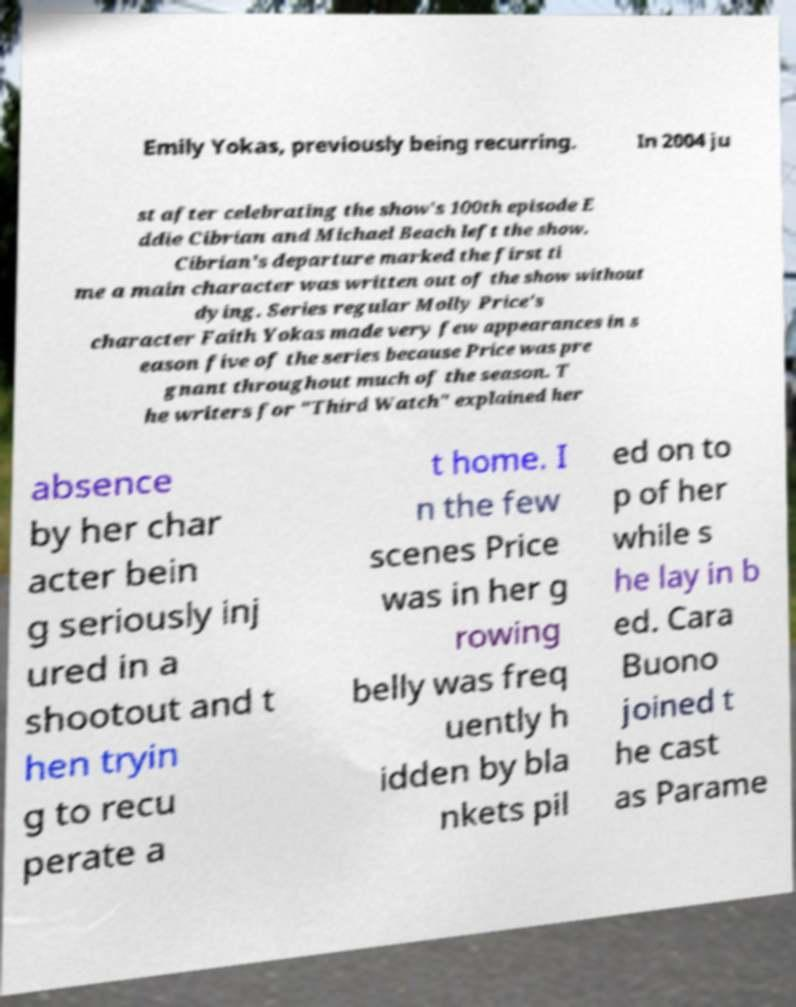Please identify and transcribe the text found in this image. Emily Yokas, previously being recurring. In 2004 ju st after celebrating the show's 100th episode E ddie Cibrian and Michael Beach left the show. Cibrian's departure marked the first ti me a main character was written out of the show without dying. Series regular Molly Price's character Faith Yokas made very few appearances in s eason five of the series because Price was pre gnant throughout much of the season. T he writers for "Third Watch" explained her absence by her char acter bein g seriously inj ured in a shootout and t hen tryin g to recu perate a t home. I n the few scenes Price was in her g rowing belly was freq uently h idden by bla nkets pil ed on to p of her while s he lay in b ed. Cara Buono joined t he cast as Parame 